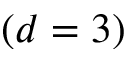Convert formula to latex. <formula><loc_0><loc_0><loc_500><loc_500>( d = 3 )</formula> 